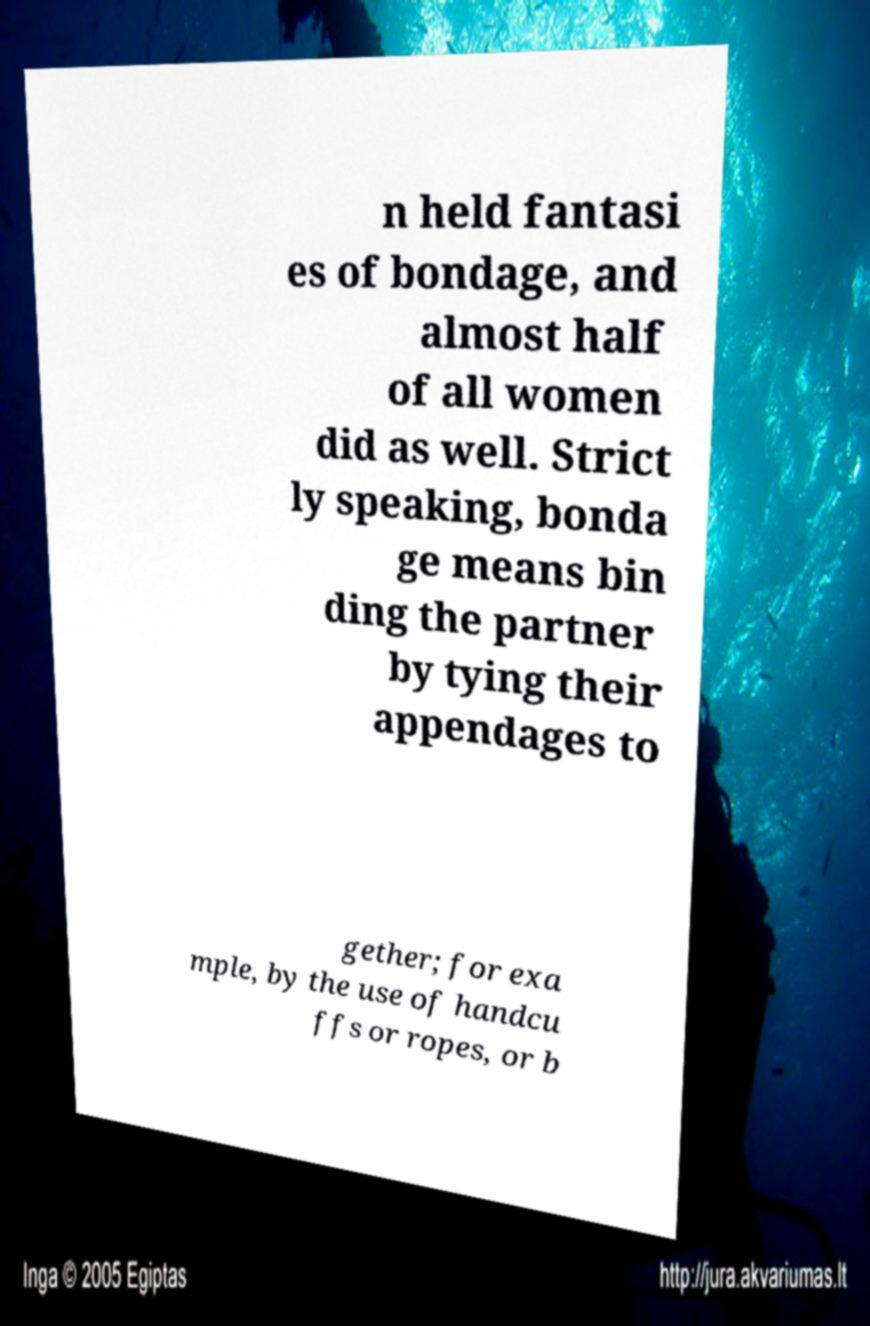There's text embedded in this image that I need extracted. Can you transcribe it verbatim? n held fantasi es of bondage, and almost half of all women did as well. Strict ly speaking, bonda ge means bin ding the partner by tying their appendages to gether; for exa mple, by the use of handcu ffs or ropes, or b 